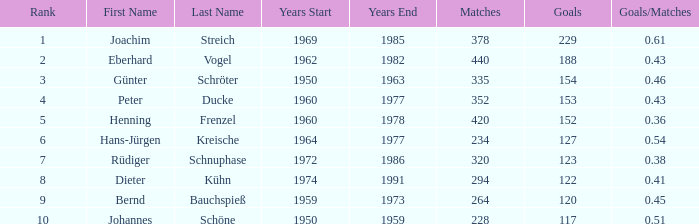What years have goals less than 229, and 440 as matches? 1962–1982. Give me the full table as a dictionary. {'header': ['Rank', 'First Name', 'Last Name', 'Years Start', 'Years End', 'Matches', 'Goals', 'Goals/Matches'], 'rows': [['1', 'Joachim', 'Streich', '1969', '1985', '378', '229', '0.61'], ['2', 'Eberhard', 'Vogel', '1962', '1982', '440', '188', '0.43'], ['3', 'Günter', 'Schröter', '1950', '1963', '335', '154', '0.46'], ['4', 'Peter', 'Ducke', '1960', '1977', '352', '153', '0.43'], ['5', 'Henning', 'Frenzel', '1960', '1978', '420', '152', '0.36'], ['6', 'Hans-Jürgen', 'Kreische', '1964', '1977', '234', '127', '0.54'], ['7', 'Rüdiger', 'Schnuphase', '1972', '1986', '320', '123', '0.38'], ['8', 'Dieter', 'Kühn', '1974', '1991', '294', '122', '0.41'], ['9', 'Bernd', 'Bauchspieß', '1959', '1973', '264', '120', '0.45'], ['10', 'Johannes', 'Schöne', '1950', '1959', '228', '117', '0.51']]} 